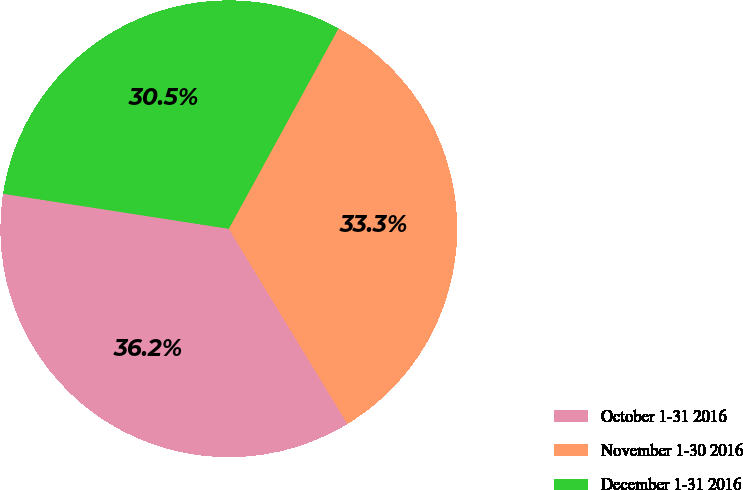Convert chart to OTSL. <chart><loc_0><loc_0><loc_500><loc_500><pie_chart><fcel>October 1-31 2016<fcel>November 1-30 2016<fcel>December 1-31 2016<nl><fcel>36.15%<fcel>33.33%<fcel>30.52%<nl></chart> 